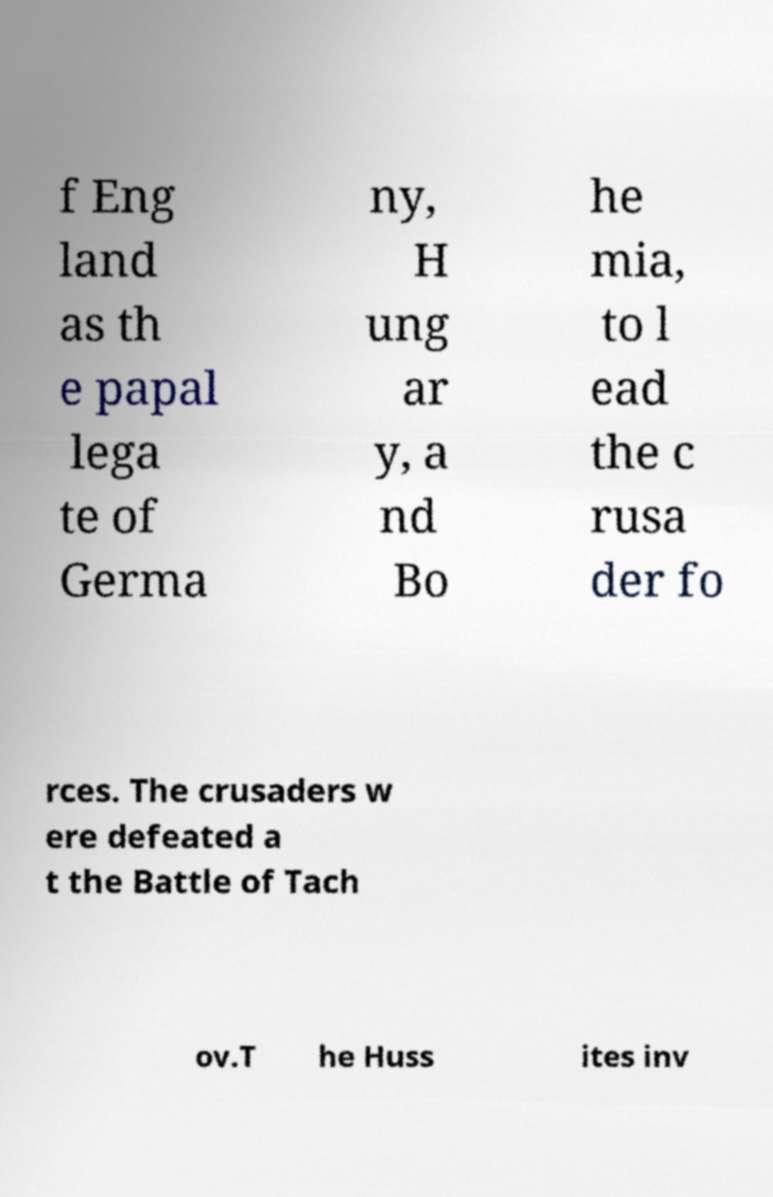Can you read and provide the text displayed in the image?This photo seems to have some interesting text. Can you extract and type it out for me? f Eng land as th e papal lega te of Germa ny, H ung ar y, a nd Bo he mia, to l ead the c rusa der fo rces. The crusaders w ere defeated a t the Battle of Tach ov.T he Huss ites inv 